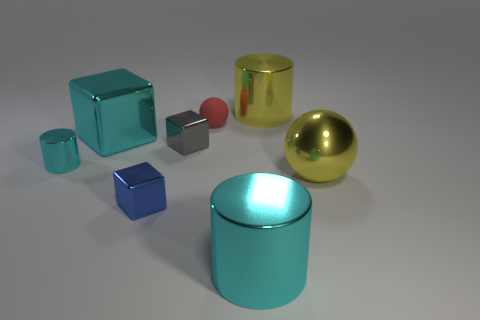Is there any other thing that is made of the same material as the red ball?
Keep it short and to the point. No. What number of large shiny things are the same shape as the rubber thing?
Give a very brief answer. 1. Are the yellow ball and the cylinder behind the gray object made of the same material?
Offer a terse response. Yes. Is the number of big yellow metal objects behind the tiny cyan metal object greater than the number of yellow metal cubes?
Keep it short and to the point. Yes. The large object that is the same color as the large shiny cube is what shape?
Your answer should be very brief. Cylinder. Are there any yellow cylinders made of the same material as the large block?
Provide a succinct answer. Yes. Is the cylinder on the left side of the small gray metallic thing made of the same material as the ball behind the yellow ball?
Your answer should be compact. No. Are there an equal number of small blue shiny blocks on the left side of the tiny metal cylinder and cyan metallic objects that are in front of the blue metallic object?
Provide a succinct answer. No. There is a sphere that is the same size as the blue metal object; what is its color?
Give a very brief answer. Red. Are there any cylinders of the same color as the large ball?
Make the answer very short. Yes. 